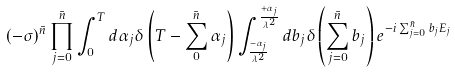Convert formula to latex. <formula><loc_0><loc_0><loc_500><loc_500>( - \sigma ) ^ { \bar { n } } \prod _ { j = 0 } ^ { \bar { n } } \int _ { 0 } ^ { T } d \alpha _ { j } \delta \left ( T - \sum _ { 0 } ^ { \bar { n } } \alpha _ { j } \right ) \int _ { \frac { - \alpha _ { j } } { \lambda ^ { 2 } } } ^ { \frac { + \alpha _ { j } } { \lambda ^ { 2 } } } d b _ { j } \delta \left ( \sum _ { j = 0 } ^ { \bar { n } } b _ { j } \right ) e ^ { - i \sum _ { j = 0 } ^ { \bar { n } } b _ { j } E _ { j } }</formula> 